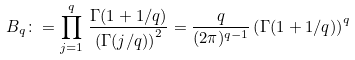Convert formula to latex. <formula><loc_0><loc_0><loc_500><loc_500>B _ { q } \colon = \prod ^ { q } _ { j = 1 } \, \frac { \Gamma ( 1 + 1 / q ) } { \left ( \Gamma ( j / q ) \right ) ^ { 2 } } = \frac { q } { ( 2 \pi ) ^ { q - 1 } } \left ( \Gamma ( 1 + 1 / q ) \right ) ^ { q }</formula> 